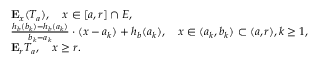<formula> <loc_0><loc_0><loc_500><loc_500>\begin{array} { r l } & { E _ { x } ( T _ { a } ) , \quad x \in [ a , r ] \cap E , } \\ & { \frac { h _ { b } ( b _ { k } ) - h _ { b } ( a _ { k } ) } { b _ { k } - a _ { k } } \cdot ( x - a _ { k } ) + h _ { b } ( a _ { k } ) , \quad x \in ( a _ { k } , b _ { k } ) \subset ( a , r ) , k \geq 1 , } \\ & { E _ { r } T _ { a } , \quad x \geq r . } \end{array}</formula> 